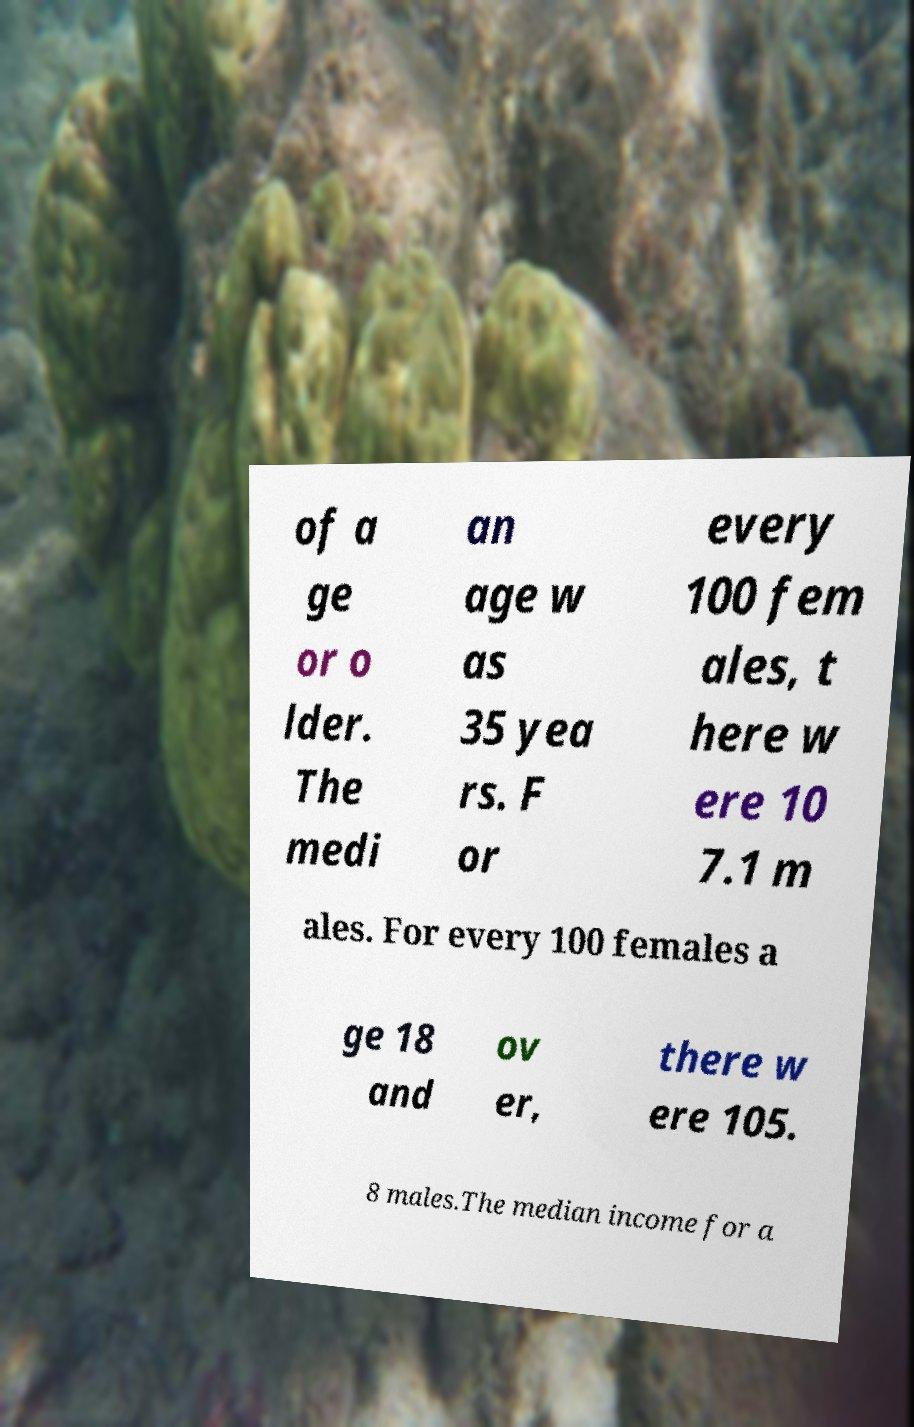Can you accurately transcribe the text from the provided image for me? of a ge or o lder. The medi an age w as 35 yea rs. F or every 100 fem ales, t here w ere 10 7.1 m ales. For every 100 females a ge 18 and ov er, there w ere 105. 8 males.The median income for a 